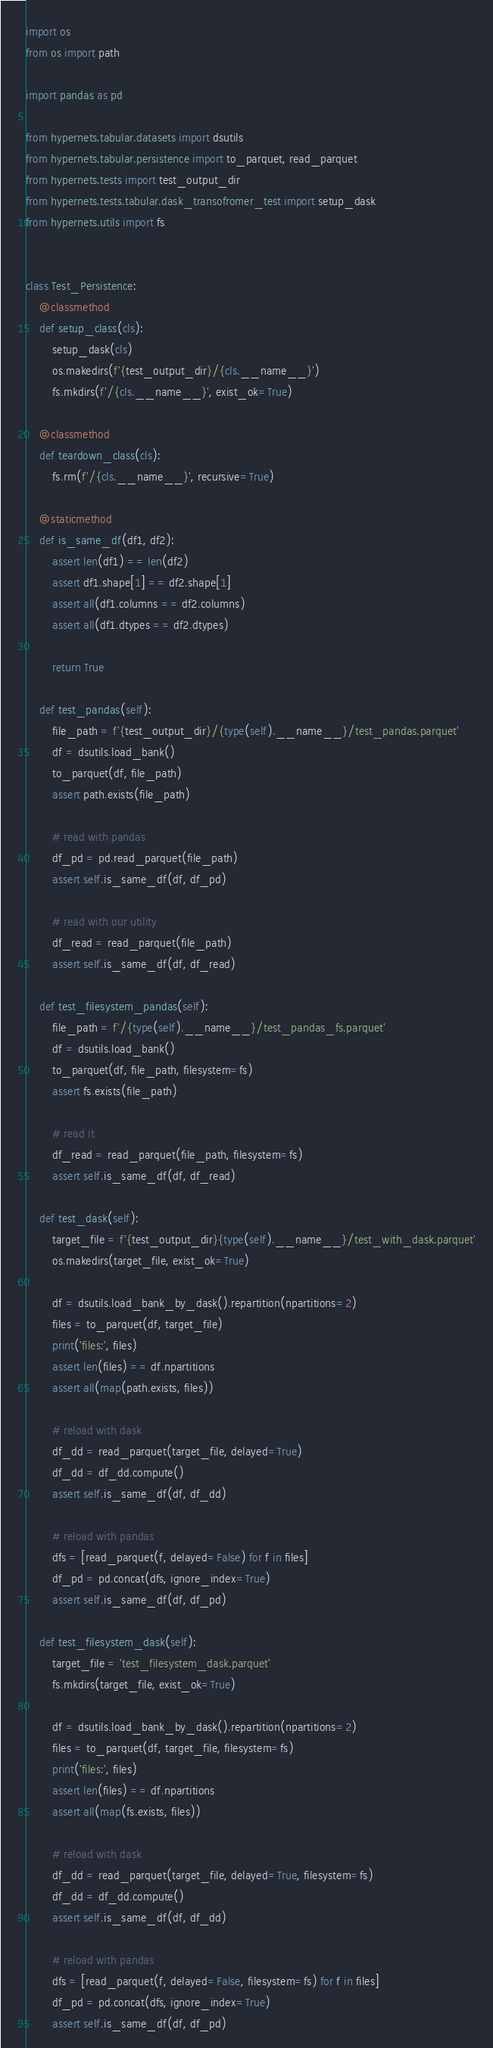<code> <loc_0><loc_0><loc_500><loc_500><_Python_>import os
from os import path

import pandas as pd

from hypernets.tabular.datasets import dsutils
from hypernets.tabular.persistence import to_parquet, read_parquet
from hypernets.tests import test_output_dir
from hypernets.tests.tabular.dask_transofromer_test import setup_dask
from hypernets.utils import fs


class Test_Persistence:
    @classmethod
    def setup_class(cls):
        setup_dask(cls)
        os.makedirs(f'{test_output_dir}/{cls.__name__}')
        fs.mkdirs(f'/{cls.__name__}', exist_ok=True)

    @classmethod
    def teardown_class(cls):
        fs.rm(f'/{cls.__name__}', recursive=True)

    @staticmethod
    def is_same_df(df1, df2):
        assert len(df1) == len(df2)
        assert df1.shape[1] == df2.shape[1]
        assert all(df1.columns == df2.columns)
        assert all(df1.dtypes == df2.dtypes)

        return True

    def test_pandas(self):
        file_path = f'{test_output_dir}/{type(self).__name__}/test_pandas.parquet'
        df = dsutils.load_bank()
        to_parquet(df, file_path)
        assert path.exists(file_path)

        # read with pandas
        df_pd = pd.read_parquet(file_path)
        assert self.is_same_df(df, df_pd)

        # read with our utility
        df_read = read_parquet(file_path)
        assert self.is_same_df(df, df_read)

    def test_filesystem_pandas(self):
        file_path = f'/{type(self).__name__}/test_pandas_fs.parquet'
        df = dsutils.load_bank()
        to_parquet(df, file_path, filesystem=fs)
        assert fs.exists(file_path)

        # read it
        df_read = read_parquet(file_path, filesystem=fs)
        assert self.is_same_df(df, df_read)

    def test_dask(self):
        target_file = f'{test_output_dir}{type(self).__name__}/test_with_dask.parquet'
        os.makedirs(target_file, exist_ok=True)

        df = dsutils.load_bank_by_dask().repartition(npartitions=2)
        files = to_parquet(df, target_file)
        print('files:', files)
        assert len(files) == df.npartitions
        assert all(map(path.exists, files))

        # reload with dask
        df_dd = read_parquet(target_file, delayed=True)
        df_dd = df_dd.compute()
        assert self.is_same_df(df, df_dd)

        # reload with pandas
        dfs = [read_parquet(f, delayed=False) for f in files]
        df_pd = pd.concat(dfs, ignore_index=True)
        assert self.is_same_df(df, df_pd)

    def test_filesystem_dask(self):
        target_file = 'test_filesystem_dask.parquet'
        fs.mkdirs(target_file, exist_ok=True)

        df = dsutils.load_bank_by_dask().repartition(npartitions=2)
        files = to_parquet(df, target_file, filesystem=fs)
        print('files:', files)
        assert len(files) == df.npartitions
        assert all(map(fs.exists, files))

        # reload with dask
        df_dd = read_parquet(target_file, delayed=True, filesystem=fs)
        df_dd = df_dd.compute()
        assert self.is_same_df(df, df_dd)

        # reload with pandas
        dfs = [read_parquet(f, delayed=False, filesystem=fs) for f in files]
        df_pd = pd.concat(dfs, ignore_index=True)
        assert self.is_same_df(df, df_pd)
</code> 